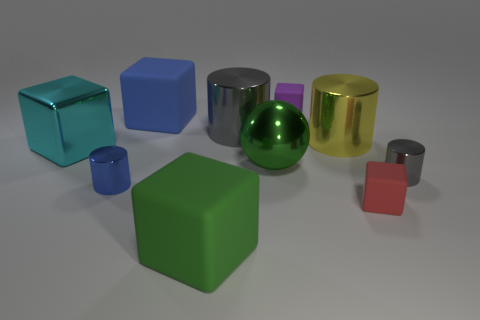How many objects are large green metal blocks or big green cubes?
Ensure brevity in your answer.  1. There is a small thing behind the large green shiny thing; what color is it?
Make the answer very short. Purple. Is the number of blue blocks that are to the left of the tiny blue thing less than the number of big green metal things?
Keep it short and to the point. Yes. There is a matte cube that is the same color as the sphere; what size is it?
Keep it short and to the point. Large. Is there any other thing that is the same size as the red block?
Your response must be concise. Yes. Do the sphere and the tiny blue cylinder have the same material?
Your response must be concise. Yes. How many objects are either small gray metallic cylinders in front of the metallic sphere or small things to the right of the red matte block?
Make the answer very short. 1. Are there any green metal balls of the same size as the yellow object?
Provide a succinct answer. Yes. The big shiny thing that is the same shape as the tiny red thing is what color?
Provide a succinct answer. Cyan. There is a gray object that is on the left side of the tiny gray object; are there any big green metallic spheres behind it?
Ensure brevity in your answer.  No. 